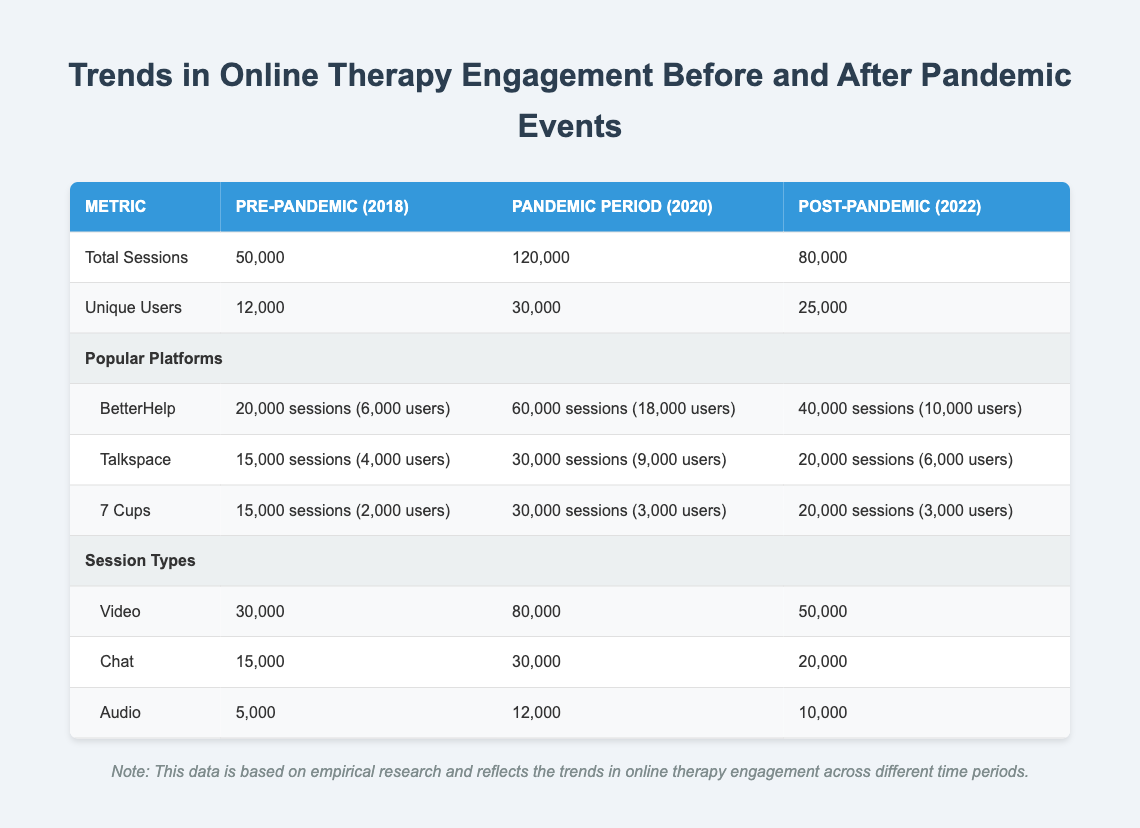What was the total number of sessions in the Pandemic Period? The table shows that during the Pandemic Period (2020), the total number of sessions was listed directly under that column, which is 120,000.
Answer: 120,000 How many unique users engaged in online therapy in 2018? According to the table, the number of unique users for the Pre-Pandemic year (2018) is presented explicitly in that section, which is 12,000.
Answer: 12,000 What percentage increase in total sessions occurred from the Pre-Pandemic period to the Pandemic Period? First, identify the total sessions in both periods: 50,000 (Pre-Pandemic) and 120,000 (Pandemic). Then calculate the increase: 120,000 - 50,000 = 70,000. Next, find the percentage increase: (70,000 / 50,000) * 100 = 140%.
Answer: 140% Did the number of unique users decrease from the Pandemic Period to Post-Pandemic? By comparing the numbers, the Pandemic Period had 30,000 unique users while the Post-Pandemic period had 25,000. Since 25,000 is less than 30,000, it confirms a decrease.
Answer: Yes How many more sessions were conducted through video compared to audio in 2020? From the table, there were 80,000 video sessions and 12,000 audio sessions during the Pandemic Period. The difference is calculated as 80,000 - 12,000 = 68,000.
Answer: 68,000 What was the total number of sessions for BetterHelp in Post-Pandemic compared to Pre-Pandemic? BetterHelp had 20,000 sessions in Pre-Pandemic and 40,000 sessions in Post-Pandemic. The difference is calculated as 40,000 - 20,000 = 20,000 sessions more.
Answer: 20,000 How many total sessions were recorded for 7 Cups during the Pandemic Period? The table specifically provides the number of sessions for 7 Cups, which is 30,000 during the Pandemic Period.
Answer: 30,000 Which platform had the highest number of users in the Pandemic Period? In the Pandemic Period, BetterHelp had 18,000 users, Talkspace had 9,000, and 7 Cups had 3,000. The highest number is 18,000 for BetterHelp.
Answer: BetterHelp What is the average number of sessions across all platforms in the Post-Pandemic period? For Post-Pandemic, the sessions for each platform are: BetterHelp (40,000), Talkspace (20,000), and 7 Cups (20,000). Adding them gives us a total of 40,000 + 20,000 + 20,000 = 80,000. To find the average: 80,000 / 3 = 26,666.67.
Answer: 26,667 